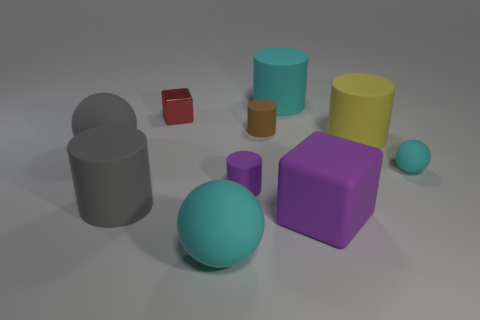Subtract all big rubber balls. How many balls are left? 1 Subtract all brown cylinders. How many cylinders are left? 4 Subtract all green cylinders. Subtract all cyan blocks. How many cylinders are left? 5 Subtract all cubes. How many objects are left? 8 Subtract 2 cyan spheres. How many objects are left? 8 Subtract all tiny brown matte cylinders. Subtract all large gray rubber cylinders. How many objects are left? 8 Add 2 gray balls. How many gray balls are left? 3 Add 8 cyan rubber spheres. How many cyan rubber spheres exist? 10 